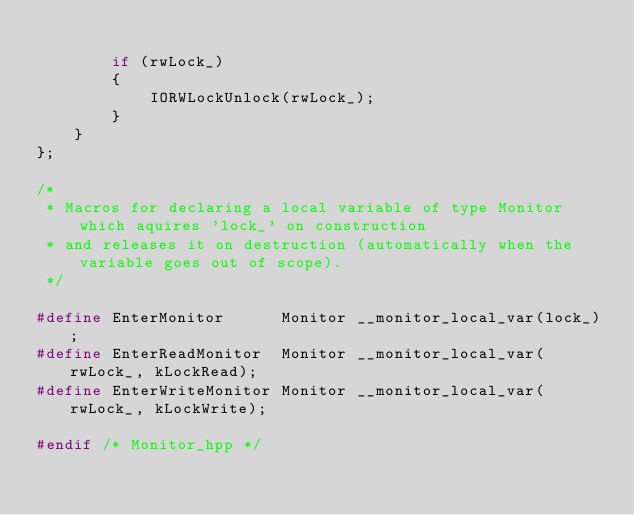Convert code to text. <code><loc_0><loc_0><loc_500><loc_500><_C++_>        
        if (rwLock_)
        {
            IORWLockUnlock(rwLock_);
        }
    }
};

/*
 * Macros for declaring a local variable of type Monitor which aquires 'lock_' on construction
 * and releases it on destruction (automatically when the variable goes out of scope).
 */

#define EnterMonitor      Monitor __monitor_local_var(lock_);
#define EnterReadMonitor  Monitor __monitor_local_var(rwLock_, kLockRead);
#define EnterWriteMonitor Monitor __monitor_local_var(rwLock_, kLockWrite);

#endif /* Monitor_hpp */
</code> 